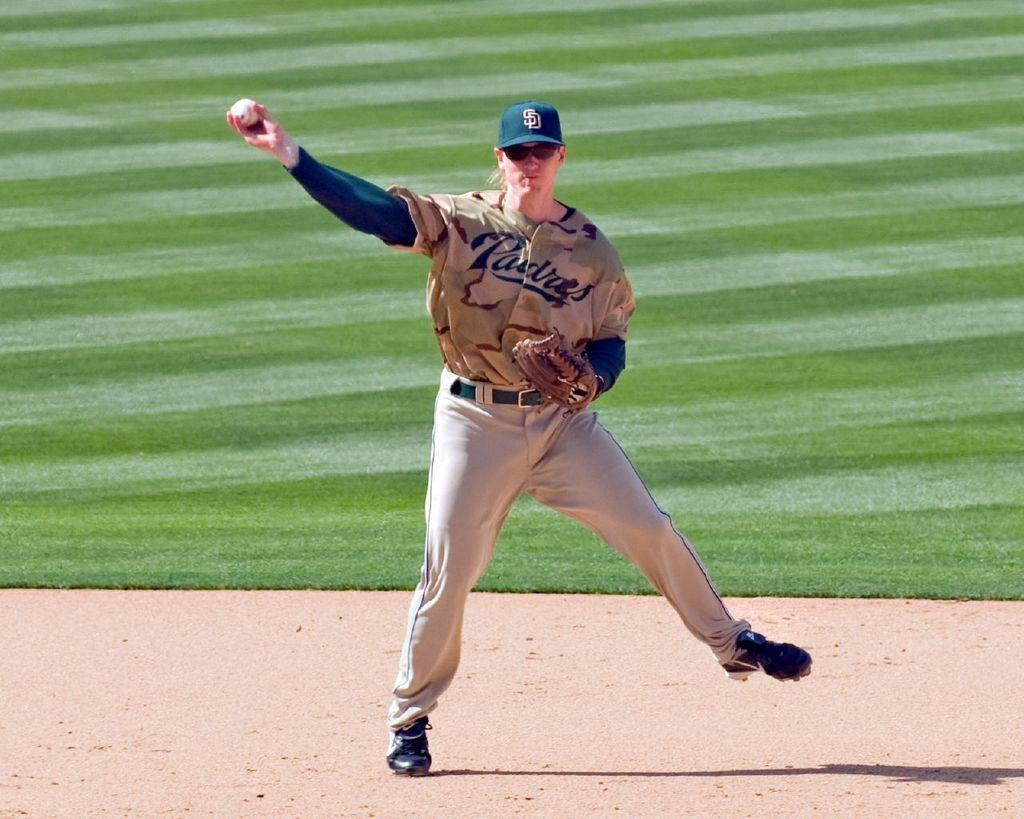Who is the main subject in the image? There is a woman in the image. Where is the woman located in the image? The woman is in the middle of the image. What accessories is the woman wearing? The woman is wearing a glove and a cap. What is the woman holding in the image? The woman is holding a ball. What type of book is the woman reading in the image? There is no book present in the image; the woman is holding a ball. Can you see a yak in the image? There is no yak present in the image. 